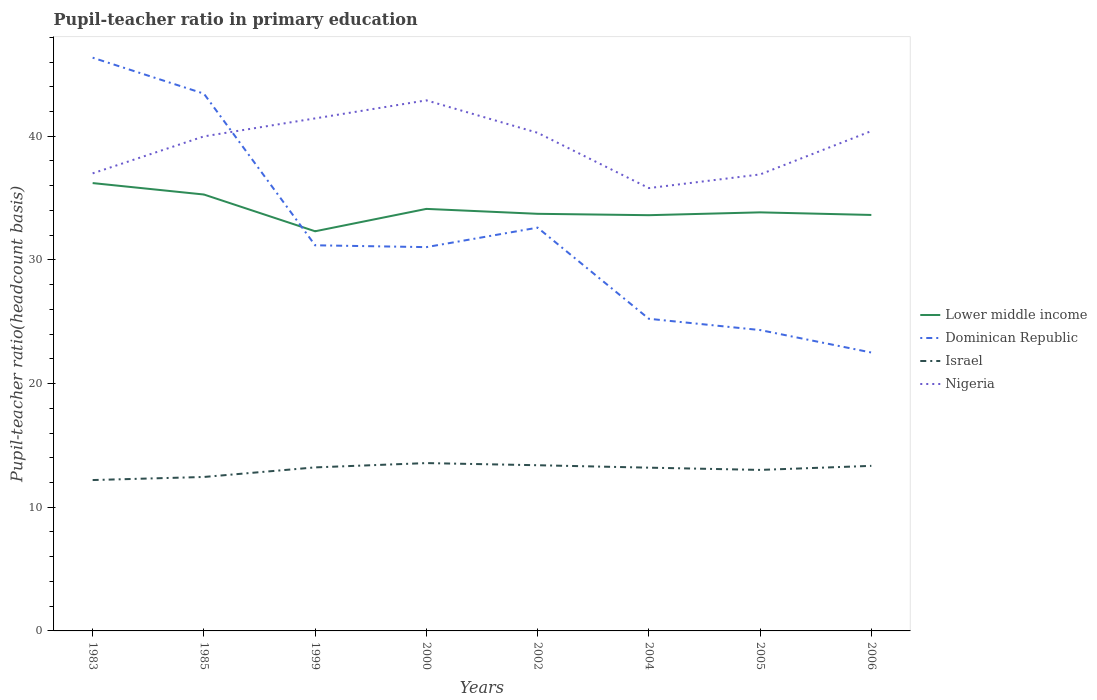Across all years, what is the maximum pupil-teacher ratio in primary education in Nigeria?
Provide a short and direct response. 35.81. In which year was the pupil-teacher ratio in primary education in Lower middle income maximum?
Ensure brevity in your answer.  1999. What is the total pupil-teacher ratio in primary education in Lower middle income in the graph?
Offer a very short reply. -0.23. What is the difference between the highest and the second highest pupil-teacher ratio in primary education in Lower middle income?
Give a very brief answer. 3.9. How many years are there in the graph?
Give a very brief answer. 8. What is the difference between two consecutive major ticks on the Y-axis?
Your answer should be compact. 10. Are the values on the major ticks of Y-axis written in scientific E-notation?
Provide a short and direct response. No. Does the graph contain grids?
Keep it short and to the point. No. Where does the legend appear in the graph?
Keep it short and to the point. Center right. How many legend labels are there?
Ensure brevity in your answer.  4. How are the legend labels stacked?
Provide a short and direct response. Vertical. What is the title of the graph?
Your response must be concise. Pupil-teacher ratio in primary education. Does "Mongolia" appear as one of the legend labels in the graph?
Your response must be concise. No. What is the label or title of the X-axis?
Your answer should be compact. Years. What is the label or title of the Y-axis?
Give a very brief answer. Pupil-teacher ratio(headcount basis). What is the Pupil-teacher ratio(headcount basis) in Lower middle income in 1983?
Your answer should be very brief. 36.21. What is the Pupil-teacher ratio(headcount basis) of Dominican Republic in 1983?
Your response must be concise. 46.35. What is the Pupil-teacher ratio(headcount basis) of Israel in 1983?
Your answer should be very brief. 12.2. What is the Pupil-teacher ratio(headcount basis) in Nigeria in 1983?
Give a very brief answer. 37. What is the Pupil-teacher ratio(headcount basis) of Lower middle income in 1985?
Provide a short and direct response. 35.29. What is the Pupil-teacher ratio(headcount basis) of Dominican Republic in 1985?
Your response must be concise. 43.44. What is the Pupil-teacher ratio(headcount basis) of Israel in 1985?
Your response must be concise. 12.45. What is the Pupil-teacher ratio(headcount basis) of Nigeria in 1985?
Make the answer very short. 39.99. What is the Pupil-teacher ratio(headcount basis) in Lower middle income in 1999?
Offer a very short reply. 32.31. What is the Pupil-teacher ratio(headcount basis) of Dominican Republic in 1999?
Provide a succinct answer. 31.18. What is the Pupil-teacher ratio(headcount basis) in Israel in 1999?
Your answer should be compact. 13.22. What is the Pupil-teacher ratio(headcount basis) of Nigeria in 1999?
Provide a succinct answer. 41.44. What is the Pupil-teacher ratio(headcount basis) of Lower middle income in 2000?
Your response must be concise. 34.12. What is the Pupil-teacher ratio(headcount basis) of Dominican Republic in 2000?
Make the answer very short. 31.03. What is the Pupil-teacher ratio(headcount basis) of Israel in 2000?
Your answer should be very brief. 13.57. What is the Pupil-teacher ratio(headcount basis) of Nigeria in 2000?
Ensure brevity in your answer.  42.9. What is the Pupil-teacher ratio(headcount basis) in Lower middle income in 2002?
Provide a short and direct response. 33.73. What is the Pupil-teacher ratio(headcount basis) in Dominican Republic in 2002?
Your response must be concise. 32.61. What is the Pupil-teacher ratio(headcount basis) in Israel in 2002?
Offer a terse response. 13.4. What is the Pupil-teacher ratio(headcount basis) in Nigeria in 2002?
Ensure brevity in your answer.  40.28. What is the Pupil-teacher ratio(headcount basis) of Lower middle income in 2004?
Offer a very short reply. 33.62. What is the Pupil-teacher ratio(headcount basis) of Dominican Republic in 2004?
Your answer should be compact. 25.24. What is the Pupil-teacher ratio(headcount basis) in Israel in 2004?
Keep it short and to the point. 13.2. What is the Pupil-teacher ratio(headcount basis) in Nigeria in 2004?
Provide a succinct answer. 35.81. What is the Pupil-teacher ratio(headcount basis) of Lower middle income in 2005?
Your answer should be compact. 33.84. What is the Pupil-teacher ratio(headcount basis) of Dominican Republic in 2005?
Offer a terse response. 24.33. What is the Pupil-teacher ratio(headcount basis) of Israel in 2005?
Your response must be concise. 13.02. What is the Pupil-teacher ratio(headcount basis) of Nigeria in 2005?
Your answer should be very brief. 36.91. What is the Pupil-teacher ratio(headcount basis) of Lower middle income in 2006?
Offer a terse response. 33.63. What is the Pupil-teacher ratio(headcount basis) in Dominican Republic in 2006?
Provide a short and direct response. 22.51. What is the Pupil-teacher ratio(headcount basis) of Israel in 2006?
Your answer should be compact. 13.35. What is the Pupil-teacher ratio(headcount basis) of Nigeria in 2006?
Your answer should be very brief. 40.42. Across all years, what is the maximum Pupil-teacher ratio(headcount basis) of Lower middle income?
Make the answer very short. 36.21. Across all years, what is the maximum Pupil-teacher ratio(headcount basis) of Dominican Republic?
Ensure brevity in your answer.  46.35. Across all years, what is the maximum Pupil-teacher ratio(headcount basis) in Israel?
Your answer should be very brief. 13.57. Across all years, what is the maximum Pupil-teacher ratio(headcount basis) of Nigeria?
Your answer should be very brief. 42.9. Across all years, what is the minimum Pupil-teacher ratio(headcount basis) in Lower middle income?
Provide a succinct answer. 32.31. Across all years, what is the minimum Pupil-teacher ratio(headcount basis) of Dominican Republic?
Keep it short and to the point. 22.51. Across all years, what is the minimum Pupil-teacher ratio(headcount basis) in Israel?
Offer a terse response. 12.2. Across all years, what is the minimum Pupil-teacher ratio(headcount basis) of Nigeria?
Offer a terse response. 35.81. What is the total Pupil-teacher ratio(headcount basis) in Lower middle income in the graph?
Your answer should be compact. 272.76. What is the total Pupil-teacher ratio(headcount basis) of Dominican Republic in the graph?
Give a very brief answer. 256.69. What is the total Pupil-teacher ratio(headcount basis) of Israel in the graph?
Provide a short and direct response. 104.4. What is the total Pupil-teacher ratio(headcount basis) of Nigeria in the graph?
Make the answer very short. 314.74. What is the difference between the Pupil-teacher ratio(headcount basis) of Lower middle income in 1983 and that in 1985?
Provide a succinct answer. 0.92. What is the difference between the Pupil-teacher ratio(headcount basis) in Dominican Republic in 1983 and that in 1985?
Your response must be concise. 2.91. What is the difference between the Pupil-teacher ratio(headcount basis) of Israel in 1983 and that in 1985?
Provide a succinct answer. -0.25. What is the difference between the Pupil-teacher ratio(headcount basis) of Nigeria in 1983 and that in 1985?
Your answer should be compact. -2.99. What is the difference between the Pupil-teacher ratio(headcount basis) of Lower middle income in 1983 and that in 1999?
Provide a succinct answer. 3.9. What is the difference between the Pupil-teacher ratio(headcount basis) of Dominican Republic in 1983 and that in 1999?
Your response must be concise. 15.17. What is the difference between the Pupil-teacher ratio(headcount basis) in Israel in 1983 and that in 1999?
Offer a terse response. -1.02. What is the difference between the Pupil-teacher ratio(headcount basis) of Nigeria in 1983 and that in 1999?
Offer a terse response. -4.44. What is the difference between the Pupil-teacher ratio(headcount basis) in Lower middle income in 1983 and that in 2000?
Your answer should be very brief. 2.09. What is the difference between the Pupil-teacher ratio(headcount basis) of Dominican Republic in 1983 and that in 2000?
Keep it short and to the point. 15.32. What is the difference between the Pupil-teacher ratio(headcount basis) of Israel in 1983 and that in 2000?
Your answer should be very brief. -1.37. What is the difference between the Pupil-teacher ratio(headcount basis) in Nigeria in 1983 and that in 2000?
Ensure brevity in your answer.  -5.9. What is the difference between the Pupil-teacher ratio(headcount basis) in Lower middle income in 1983 and that in 2002?
Give a very brief answer. 2.48. What is the difference between the Pupil-teacher ratio(headcount basis) in Dominican Republic in 1983 and that in 2002?
Make the answer very short. 13.74. What is the difference between the Pupil-teacher ratio(headcount basis) of Israel in 1983 and that in 2002?
Make the answer very short. -1.2. What is the difference between the Pupil-teacher ratio(headcount basis) of Nigeria in 1983 and that in 2002?
Your answer should be compact. -3.28. What is the difference between the Pupil-teacher ratio(headcount basis) of Lower middle income in 1983 and that in 2004?
Offer a very short reply. 2.6. What is the difference between the Pupil-teacher ratio(headcount basis) in Dominican Republic in 1983 and that in 2004?
Make the answer very short. 21.11. What is the difference between the Pupil-teacher ratio(headcount basis) in Israel in 1983 and that in 2004?
Make the answer very short. -1. What is the difference between the Pupil-teacher ratio(headcount basis) of Nigeria in 1983 and that in 2004?
Make the answer very short. 1.19. What is the difference between the Pupil-teacher ratio(headcount basis) in Lower middle income in 1983 and that in 2005?
Make the answer very short. 2.37. What is the difference between the Pupil-teacher ratio(headcount basis) in Dominican Republic in 1983 and that in 2005?
Your response must be concise. 22.02. What is the difference between the Pupil-teacher ratio(headcount basis) in Israel in 1983 and that in 2005?
Your answer should be compact. -0.82. What is the difference between the Pupil-teacher ratio(headcount basis) in Nigeria in 1983 and that in 2005?
Provide a succinct answer. 0.09. What is the difference between the Pupil-teacher ratio(headcount basis) of Lower middle income in 1983 and that in 2006?
Make the answer very short. 2.58. What is the difference between the Pupil-teacher ratio(headcount basis) of Dominican Republic in 1983 and that in 2006?
Your answer should be very brief. 23.84. What is the difference between the Pupil-teacher ratio(headcount basis) of Israel in 1983 and that in 2006?
Ensure brevity in your answer.  -1.15. What is the difference between the Pupil-teacher ratio(headcount basis) in Nigeria in 1983 and that in 2006?
Give a very brief answer. -3.42. What is the difference between the Pupil-teacher ratio(headcount basis) of Lower middle income in 1985 and that in 1999?
Provide a short and direct response. 2.97. What is the difference between the Pupil-teacher ratio(headcount basis) in Dominican Republic in 1985 and that in 1999?
Provide a succinct answer. 12.26. What is the difference between the Pupil-teacher ratio(headcount basis) of Israel in 1985 and that in 1999?
Ensure brevity in your answer.  -0.77. What is the difference between the Pupil-teacher ratio(headcount basis) in Nigeria in 1985 and that in 1999?
Offer a terse response. -1.45. What is the difference between the Pupil-teacher ratio(headcount basis) in Lower middle income in 1985 and that in 2000?
Provide a succinct answer. 1.16. What is the difference between the Pupil-teacher ratio(headcount basis) in Dominican Republic in 1985 and that in 2000?
Give a very brief answer. 12.41. What is the difference between the Pupil-teacher ratio(headcount basis) of Israel in 1985 and that in 2000?
Keep it short and to the point. -1.12. What is the difference between the Pupil-teacher ratio(headcount basis) in Nigeria in 1985 and that in 2000?
Provide a succinct answer. -2.91. What is the difference between the Pupil-teacher ratio(headcount basis) in Lower middle income in 1985 and that in 2002?
Make the answer very short. 1.56. What is the difference between the Pupil-teacher ratio(headcount basis) in Dominican Republic in 1985 and that in 2002?
Offer a terse response. 10.83. What is the difference between the Pupil-teacher ratio(headcount basis) of Israel in 1985 and that in 2002?
Keep it short and to the point. -0.95. What is the difference between the Pupil-teacher ratio(headcount basis) of Nigeria in 1985 and that in 2002?
Make the answer very short. -0.29. What is the difference between the Pupil-teacher ratio(headcount basis) in Lower middle income in 1985 and that in 2004?
Make the answer very short. 1.67. What is the difference between the Pupil-teacher ratio(headcount basis) of Dominican Republic in 1985 and that in 2004?
Keep it short and to the point. 18.2. What is the difference between the Pupil-teacher ratio(headcount basis) in Israel in 1985 and that in 2004?
Your answer should be compact. -0.75. What is the difference between the Pupil-teacher ratio(headcount basis) in Nigeria in 1985 and that in 2004?
Your answer should be compact. 4.18. What is the difference between the Pupil-teacher ratio(headcount basis) of Lower middle income in 1985 and that in 2005?
Provide a short and direct response. 1.44. What is the difference between the Pupil-teacher ratio(headcount basis) of Dominican Republic in 1985 and that in 2005?
Provide a succinct answer. 19.11. What is the difference between the Pupil-teacher ratio(headcount basis) in Israel in 1985 and that in 2005?
Your answer should be very brief. -0.57. What is the difference between the Pupil-teacher ratio(headcount basis) of Nigeria in 1985 and that in 2005?
Give a very brief answer. 3.08. What is the difference between the Pupil-teacher ratio(headcount basis) in Lower middle income in 1985 and that in 2006?
Offer a terse response. 1.65. What is the difference between the Pupil-teacher ratio(headcount basis) in Dominican Republic in 1985 and that in 2006?
Provide a short and direct response. 20.93. What is the difference between the Pupil-teacher ratio(headcount basis) in Israel in 1985 and that in 2006?
Provide a succinct answer. -0.9. What is the difference between the Pupil-teacher ratio(headcount basis) in Nigeria in 1985 and that in 2006?
Make the answer very short. -0.43. What is the difference between the Pupil-teacher ratio(headcount basis) of Lower middle income in 1999 and that in 2000?
Make the answer very short. -1.81. What is the difference between the Pupil-teacher ratio(headcount basis) of Dominican Republic in 1999 and that in 2000?
Ensure brevity in your answer.  0.15. What is the difference between the Pupil-teacher ratio(headcount basis) of Israel in 1999 and that in 2000?
Ensure brevity in your answer.  -0.35. What is the difference between the Pupil-teacher ratio(headcount basis) in Nigeria in 1999 and that in 2000?
Your response must be concise. -1.46. What is the difference between the Pupil-teacher ratio(headcount basis) in Lower middle income in 1999 and that in 2002?
Ensure brevity in your answer.  -1.41. What is the difference between the Pupil-teacher ratio(headcount basis) in Dominican Republic in 1999 and that in 2002?
Ensure brevity in your answer.  -1.43. What is the difference between the Pupil-teacher ratio(headcount basis) in Israel in 1999 and that in 2002?
Your response must be concise. -0.17. What is the difference between the Pupil-teacher ratio(headcount basis) in Nigeria in 1999 and that in 2002?
Provide a succinct answer. 1.17. What is the difference between the Pupil-teacher ratio(headcount basis) of Lower middle income in 1999 and that in 2004?
Provide a short and direct response. -1.3. What is the difference between the Pupil-teacher ratio(headcount basis) in Dominican Republic in 1999 and that in 2004?
Keep it short and to the point. 5.94. What is the difference between the Pupil-teacher ratio(headcount basis) of Israel in 1999 and that in 2004?
Your answer should be very brief. 0.02. What is the difference between the Pupil-teacher ratio(headcount basis) of Nigeria in 1999 and that in 2004?
Make the answer very short. 5.64. What is the difference between the Pupil-teacher ratio(headcount basis) in Lower middle income in 1999 and that in 2005?
Provide a short and direct response. -1.53. What is the difference between the Pupil-teacher ratio(headcount basis) of Dominican Republic in 1999 and that in 2005?
Provide a short and direct response. 6.85. What is the difference between the Pupil-teacher ratio(headcount basis) of Israel in 1999 and that in 2005?
Ensure brevity in your answer.  0.2. What is the difference between the Pupil-teacher ratio(headcount basis) of Nigeria in 1999 and that in 2005?
Your answer should be very brief. 4.53. What is the difference between the Pupil-teacher ratio(headcount basis) in Lower middle income in 1999 and that in 2006?
Provide a short and direct response. -1.32. What is the difference between the Pupil-teacher ratio(headcount basis) of Dominican Republic in 1999 and that in 2006?
Your response must be concise. 8.67. What is the difference between the Pupil-teacher ratio(headcount basis) in Israel in 1999 and that in 2006?
Keep it short and to the point. -0.12. What is the difference between the Pupil-teacher ratio(headcount basis) in Nigeria in 1999 and that in 2006?
Your answer should be very brief. 1.02. What is the difference between the Pupil-teacher ratio(headcount basis) in Lower middle income in 2000 and that in 2002?
Your answer should be compact. 0.4. What is the difference between the Pupil-teacher ratio(headcount basis) in Dominican Republic in 2000 and that in 2002?
Keep it short and to the point. -1.58. What is the difference between the Pupil-teacher ratio(headcount basis) in Israel in 2000 and that in 2002?
Provide a short and direct response. 0.17. What is the difference between the Pupil-teacher ratio(headcount basis) of Nigeria in 2000 and that in 2002?
Ensure brevity in your answer.  2.62. What is the difference between the Pupil-teacher ratio(headcount basis) of Lower middle income in 2000 and that in 2004?
Give a very brief answer. 0.51. What is the difference between the Pupil-teacher ratio(headcount basis) in Dominican Republic in 2000 and that in 2004?
Offer a very short reply. 5.79. What is the difference between the Pupil-teacher ratio(headcount basis) in Israel in 2000 and that in 2004?
Your response must be concise. 0.37. What is the difference between the Pupil-teacher ratio(headcount basis) of Nigeria in 2000 and that in 2004?
Keep it short and to the point. 7.09. What is the difference between the Pupil-teacher ratio(headcount basis) in Lower middle income in 2000 and that in 2005?
Your response must be concise. 0.28. What is the difference between the Pupil-teacher ratio(headcount basis) of Dominican Republic in 2000 and that in 2005?
Ensure brevity in your answer.  6.7. What is the difference between the Pupil-teacher ratio(headcount basis) of Israel in 2000 and that in 2005?
Keep it short and to the point. 0.55. What is the difference between the Pupil-teacher ratio(headcount basis) in Nigeria in 2000 and that in 2005?
Offer a terse response. 5.99. What is the difference between the Pupil-teacher ratio(headcount basis) in Lower middle income in 2000 and that in 2006?
Your answer should be compact. 0.49. What is the difference between the Pupil-teacher ratio(headcount basis) of Dominican Republic in 2000 and that in 2006?
Provide a short and direct response. 8.52. What is the difference between the Pupil-teacher ratio(headcount basis) of Israel in 2000 and that in 2006?
Provide a succinct answer. 0.22. What is the difference between the Pupil-teacher ratio(headcount basis) of Nigeria in 2000 and that in 2006?
Provide a succinct answer. 2.48. What is the difference between the Pupil-teacher ratio(headcount basis) of Lower middle income in 2002 and that in 2004?
Your response must be concise. 0.11. What is the difference between the Pupil-teacher ratio(headcount basis) in Dominican Republic in 2002 and that in 2004?
Offer a very short reply. 7.37. What is the difference between the Pupil-teacher ratio(headcount basis) in Israel in 2002 and that in 2004?
Keep it short and to the point. 0.2. What is the difference between the Pupil-teacher ratio(headcount basis) in Nigeria in 2002 and that in 2004?
Offer a terse response. 4.47. What is the difference between the Pupil-teacher ratio(headcount basis) of Lower middle income in 2002 and that in 2005?
Offer a terse response. -0.12. What is the difference between the Pupil-teacher ratio(headcount basis) of Dominican Republic in 2002 and that in 2005?
Give a very brief answer. 8.28. What is the difference between the Pupil-teacher ratio(headcount basis) of Israel in 2002 and that in 2005?
Ensure brevity in your answer.  0.38. What is the difference between the Pupil-teacher ratio(headcount basis) of Nigeria in 2002 and that in 2005?
Keep it short and to the point. 3.37. What is the difference between the Pupil-teacher ratio(headcount basis) in Lower middle income in 2002 and that in 2006?
Your answer should be compact. 0.09. What is the difference between the Pupil-teacher ratio(headcount basis) in Dominican Republic in 2002 and that in 2006?
Keep it short and to the point. 10.1. What is the difference between the Pupil-teacher ratio(headcount basis) of Israel in 2002 and that in 2006?
Keep it short and to the point. 0.05. What is the difference between the Pupil-teacher ratio(headcount basis) of Nigeria in 2002 and that in 2006?
Offer a very short reply. -0.14. What is the difference between the Pupil-teacher ratio(headcount basis) in Lower middle income in 2004 and that in 2005?
Keep it short and to the point. -0.23. What is the difference between the Pupil-teacher ratio(headcount basis) of Dominican Republic in 2004 and that in 2005?
Ensure brevity in your answer.  0.91. What is the difference between the Pupil-teacher ratio(headcount basis) of Israel in 2004 and that in 2005?
Your response must be concise. 0.18. What is the difference between the Pupil-teacher ratio(headcount basis) of Nigeria in 2004 and that in 2005?
Provide a short and direct response. -1.1. What is the difference between the Pupil-teacher ratio(headcount basis) in Lower middle income in 2004 and that in 2006?
Make the answer very short. -0.02. What is the difference between the Pupil-teacher ratio(headcount basis) of Dominican Republic in 2004 and that in 2006?
Give a very brief answer. 2.73. What is the difference between the Pupil-teacher ratio(headcount basis) of Israel in 2004 and that in 2006?
Provide a short and direct response. -0.15. What is the difference between the Pupil-teacher ratio(headcount basis) in Nigeria in 2004 and that in 2006?
Give a very brief answer. -4.61. What is the difference between the Pupil-teacher ratio(headcount basis) in Lower middle income in 2005 and that in 2006?
Make the answer very short. 0.21. What is the difference between the Pupil-teacher ratio(headcount basis) in Dominican Republic in 2005 and that in 2006?
Give a very brief answer. 1.82. What is the difference between the Pupil-teacher ratio(headcount basis) of Israel in 2005 and that in 2006?
Provide a succinct answer. -0.33. What is the difference between the Pupil-teacher ratio(headcount basis) of Nigeria in 2005 and that in 2006?
Give a very brief answer. -3.51. What is the difference between the Pupil-teacher ratio(headcount basis) of Lower middle income in 1983 and the Pupil-teacher ratio(headcount basis) of Dominican Republic in 1985?
Provide a succinct answer. -7.23. What is the difference between the Pupil-teacher ratio(headcount basis) of Lower middle income in 1983 and the Pupil-teacher ratio(headcount basis) of Israel in 1985?
Offer a very short reply. 23.76. What is the difference between the Pupil-teacher ratio(headcount basis) in Lower middle income in 1983 and the Pupil-teacher ratio(headcount basis) in Nigeria in 1985?
Provide a succinct answer. -3.78. What is the difference between the Pupil-teacher ratio(headcount basis) of Dominican Republic in 1983 and the Pupil-teacher ratio(headcount basis) of Israel in 1985?
Give a very brief answer. 33.9. What is the difference between the Pupil-teacher ratio(headcount basis) of Dominican Republic in 1983 and the Pupil-teacher ratio(headcount basis) of Nigeria in 1985?
Provide a short and direct response. 6.36. What is the difference between the Pupil-teacher ratio(headcount basis) in Israel in 1983 and the Pupil-teacher ratio(headcount basis) in Nigeria in 1985?
Ensure brevity in your answer.  -27.79. What is the difference between the Pupil-teacher ratio(headcount basis) in Lower middle income in 1983 and the Pupil-teacher ratio(headcount basis) in Dominican Republic in 1999?
Provide a short and direct response. 5.03. What is the difference between the Pupil-teacher ratio(headcount basis) in Lower middle income in 1983 and the Pupil-teacher ratio(headcount basis) in Israel in 1999?
Keep it short and to the point. 22.99. What is the difference between the Pupil-teacher ratio(headcount basis) in Lower middle income in 1983 and the Pupil-teacher ratio(headcount basis) in Nigeria in 1999?
Your answer should be very brief. -5.23. What is the difference between the Pupil-teacher ratio(headcount basis) in Dominican Republic in 1983 and the Pupil-teacher ratio(headcount basis) in Israel in 1999?
Provide a short and direct response. 33.13. What is the difference between the Pupil-teacher ratio(headcount basis) in Dominican Republic in 1983 and the Pupil-teacher ratio(headcount basis) in Nigeria in 1999?
Keep it short and to the point. 4.91. What is the difference between the Pupil-teacher ratio(headcount basis) in Israel in 1983 and the Pupil-teacher ratio(headcount basis) in Nigeria in 1999?
Your response must be concise. -29.24. What is the difference between the Pupil-teacher ratio(headcount basis) of Lower middle income in 1983 and the Pupil-teacher ratio(headcount basis) of Dominican Republic in 2000?
Give a very brief answer. 5.18. What is the difference between the Pupil-teacher ratio(headcount basis) in Lower middle income in 1983 and the Pupil-teacher ratio(headcount basis) in Israel in 2000?
Your answer should be very brief. 22.64. What is the difference between the Pupil-teacher ratio(headcount basis) in Lower middle income in 1983 and the Pupil-teacher ratio(headcount basis) in Nigeria in 2000?
Offer a very short reply. -6.69. What is the difference between the Pupil-teacher ratio(headcount basis) in Dominican Republic in 1983 and the Pupil-teacher ratio(headcount basis) in Israel in 2000?
Your answer should be very brief. 32.78. What is the difference between the Pupil-teacher ratio(headcount basis) of Dominican Republic in 1983 and the Pupil-teacher ratio(headcount basis) of Nigeria in 2000?
Provide a short and direct response. 3.45. What is the difference between the Pupil-teacher ratio(headcount basis) of Israel in 1983 and the Pupil-teacher ratio(headcount basis) of Nigeria in 2000?
Your answer should be very brief. -30.7. What is the difference between the Pupil-teacher ratio(headcount basis) of Lower middle income in 1983 and the Pupil-teacher ratio(headcount basis) of Dominican Republic in 2002?
Your answer should be very brief. 3.6. What is the difference between the Pupil-teacher ratio(headcount basis) in Lower middle income in 1983 and the Pupil-teacher ratio(headcount basis) in Israel in 2002?
Provide a succinct answer. 22.81. What is the difference between the Pupil-teacher ratio(headcount basis) of Lower middle income in 1983 and the Pupil-teacher ratio(headcount basis) of Nigeria in 2002?
Ensure brevity in your answer.  -4.07. What is the difference between the Pupil-teacher ratio(headcount basis) in Dominican Republic in 1983 and the Pupil-teacher ratio(headcount basis) in Israel in 2002?
Your response must be concise. 32.95. What is the difference between the Pupil-teacher ratio(headcount basis) of Dominican Republic in 1983 and the Pupil-teacher ratio(headcount basis) of Nigeria in 2002?
Make the answer very short. 6.07. What is the difference between the Pupil-teacher ratio(headcount basis) in Israel in 1983 and the Pupil-teacher ratio(headcount basis) in Nigeria in 2002?
Ensure brevity in your answer.  -28.08. What is the difference between the Pupil-teacher ratio(headcount basis) in Lower middle income in 1983 and the Pupil-teacher ratio(headcount basis) in Dominican Republic in 2004?
Your answer should be very brief. 10.97. What is the difference between the Pupil-teacher ratio(headcount basis) of Lower middle income in 1983 and the Pupil-teacher ratio(headcount basis) of Israel in 2004?
Provide a short and direct response. 23.01. What is the difference between the Pupil-teacher ratio(headcount basis) of Lower middle income in 1983 and the Pupil-teacher ratio(headcount basis) of Nigeria in 2004?
Your answer should be compact. 0.41. What is the difference between the Pupil-teacher ratio(headcount basis) in Dominican Republic in 1983 and the Pupil-teacher ratio(headcount basis) in Israel in 2004?
Your answer should be compact. 33.15. What is the difference between the Pupil-teacher ratio(headcount basis) of Dominican Republic in 1983 and the Pupil-teacher ratio(headcount basis) of Nigeria in 2004?
Your response must be concise. 10.54. What is the difference between the Pupil-teacher ratio(headcount basis) in Israel in 1983 and the Pupil-teacher ratio(headcount basis) in Nigeria in 2004?
Your answer should be very brief. -23.61. What is the difference between the Pupil-teacher ratio(headcount basis) of Lower middle income in 1983 and the Pupil-teacher ratio(headcount basis) of Dominican Republic in 2005?
Offer a very short reply. 11.88. What is the difference between the Pupil-teacher ratio(headcount basis) of Lower middle income in 1983 and the Pupil-teacher ratio(headcount basis) of Israel in 2005?
Provide a short and direct response. 23.19. What is the difference between the Pupil-teacher ratio(headcount basis) in Lower middle income in 1983 and the Pupil-teacher ratio(headcount basis) in Nigeria in 2005?
Offer a very short reply. -0.7. What is the difference between the Pupil-teacher ratio(headcount basis) in Dominican Republic in 1983 and the Pupil-teacher ratio(headcount basis) in Israel in 2005?
Keep it short and to the point. 33.33. What is the difference between the Pupil-teacher ratio(headcount basis) in Dominican Republic in 1983 and the Pupil-teacher ratio(headcount basis) in Nigeria in 2005?
Your answer should be compact. 9.44. What is the difference between the Pupil-teacher ratio(headcount basis) in Israel in 1983 and the Pupil-teacher ratio(headcount basis) in Nigeria in 2005?
Ensure brevity in your answer.  -24.71. What is the difference between the Pupil-teacher ratio(headcount basis) in Lower middle income in 1983 and the Pupil-teacher ratio(headcount basis) in Dominican Republic in 2006?
Make the answer very short. 13.7. What is the difference between the Pupil-teacher ratio(headcount basis) in Lower middle income in 1983 and the Pupil-teacher ratio(headcount basis) in Israel in 2006?
Your answer should be compact. 22.86. What is the difference between the Pupil-teacher ratio(headcount basis) of Lower middle income in 1983 and the Pupil-teacher ratio(headcount basis) of Nigeria in 2006?
Make the answer very short. -4.21. What is the difference between the Pupil-teacher ratio(headcount basis) of Dominican Republic in 1983 and the Pupil-teacher ratio(headcount basis) of Israel in 2006?
Your response must be concise. 33. What is the difference between the Pupil-teacher ratio(headcount basis) of Dominican Republic in 1983 and the Pupil-teacher ratio(headcount basis) of Nigeria in 2006?
Offer a terse response. 5.93. What is the difference between the Pupil-teacher ratio(headcount basis) of Israel in 1983 and the Pupil-teacher ratio(headcount basis) of Nigeria in 2006?
Ensure brevity in your answer.  -28.22. What is the difference between the Pupil-teacher ratio(headcount basis) in Lower middle income in 1985 and the Pupil-teacher ratio(headcount basis) in Dominican Republic in 1999?
Your answer should be very brief. 4.11. What is the difference between the Pupil-teacher ratio(headcount basis) of Lower middle income in 1985 and the Pupil-teacher ratio(headcount basis) of Israel in 1999?
Offer a terse response. 22.06. What is the difference between the Pupil-teacher ratio(headcount basis) of Lower middle income in 1985 and the Pupil-teacher ratio(headcount basis) of Nigeria in 1999?
Your response must be concise. -6.15. What is the difference between the Pupil-teacher ratio(headcount basis) of Dominican Republic in 1985 and the Pupil-teacher ratio(headcount basis) of Israel in 1999?
Keep it short and to the point. 30.22. What is the difference between the Pupil-teacher ratio(headcount basis) of Dominican Republic in 1985 and the Pupil-teacher ratio(headcount basis) of Nigeria in 1999?
Give a very brief answer. 2. What is the difference between the Pupil-teacher ratio(headcount basis) of Israel in 1985 and the Pupil-teacher ratio(headcount basis) of Nigeria in 1999?
Your answer should be compact. -28.99. What is the difference between the Pupil-teacher ratio(headcount basis) in Lower middle income in 1985 and the Pupil-teacher ratio(headcount basis) in Dominican Republic in 2000?
Give a very brief answer. 4.25. What is the difference between the Pupil-teacher ratio(headcount basis) in Lower middle income in 1985 and the Pupil-teacher ratio(headcount basis) in Israel in 2000?
Your answer should be very brief. 21.72. What is the difference between the Pupil-teacher ratio(headcount basis) of Lower middle income in 1985 and the Pupil-teacher ratio(headcount basis) of Nigeria in 2000?
Your response must be concise. -7.61. What is the difference between the Pupil-teacher ratio(headcount basis) in Dominican Republic in 1985 and the Pupil-teacher ratio(headcount basis) in Israel in 2000?
Keep it short and to the point. 29.87. What is the difference between the Pupil-teacher ratio(headcount basis) of Dominican Republic in 1985 and the Pupil-teacher ratio(headcount basis) of Nigeria in 2000?
Your response must be concise. 0.54. What is the difference between the Pupil-teacher ratio(headcount basis) in Israel in 1985 and the Pupil-teacher ratio(headcount basis) in Nigeria in 2000?
Offer a very short reply. -30.45. What is the difference between the Pupil-teacher ratio(headcount basis) in Lower middle income in 1985 and the Pupil-teacher ratio(headcount basis) in Dominican Republic in 2002?
Make the answer very short. 2.68. What is the difference between the Pupil-teacher ratio(headcount basis) in Lower middle income in 1985 and the Pupil-teacher ratio(headcount basis) in Israel in 2002?
Offer a terse response. 21.89. What is the difference between the Pupil-teacher ratio(headcount basis) of Lower middle income in 1985 and the Pupil-teacher ratio(headcount basis) of Nigeria in 2002?
Your answer should be very brief. -4.99. What is the difference between the Pupil-teacher ratio(headcount basis) of Dominican Republic in 1985 and the Pupil-teacher ratio(headcount basis) of Israel in 2002?
Provide a succinct answer. 30.05. What is the difference between the Pupil-teacher ratio(headcount basis) of Dominican Republic in 1985 and the Pupil-teacher ratio(headcount basis) of Nigeria in 2002?
Make the answer very short. 3.17. What is the difference between the Pupil-teacher ratio(headcount basis) of Israel in 1985 and the Pupil-teacher ratio(headcount basis) of Nigeria in 2002?
Offer a terse response. -27.83. What is the difference between the Pupil-teacher ratio(headcount basis) in Lower middle income in 1985 and the Pupil-teacher ratio(headcount basis) in Dominican Republic in 2004?
Give a very brief answer. 10.05. What is the difference between the Pupil-teacher ratio(headcount basis) of Lower middle income in 1985 and the Pupil-teacher ratio(headcount basis) of Israel in 2004?
Give a very brief answer. 22.09. What is the difference between the Pupil-teacher ratio(headcount basis) of Lower middle income in 1985 and the Pupil-teacher ratio(headcount basis) of Nigeria in 2004?
Give a very brief answer. -0.52. What is the difference between the Pupil-teacher ratio(headcount basis) in Dominican Republic in 1985 and the Pupil-teacher ratio(headcount basis) in Israel in 2004?
Your response must be concise. 30.24. What is the difference between the Pupil-teacher ratio(headcount basis) in Dominican Republic in 1985 and the Pupil-teacher ratio(headcount basis) in Nigeria in 2004?
Provide a short and direct response. 7.64. What is the difference between the Pupil-teacher ratio(headcount basis) in Israel in 1985 and the Pupil-teacher ratio(headcount basis) in Nigeria in 2004?
Give a very brief answer. -23.36. What is the difference between the Pupil-teacher ratio(headcount basis) in Lower middle income in 1985 and the Pupil-teacher ratio(headcount basis) in Dominican Republic in 2005?
Offer a terse response. 10.96. What is the difference between the Pupil-teacher ratio(headcount basis) of Lower middle income in 1985 and the Pupil-teacher ratio(headcount basis) of Israel in 2005?
Offer a terse response. 22.27. What is the difference between the Pupil-teacher ratio(headcount basis) in Lower middle income in 1985 and the Pupil-teacher ratio(headcount basis) in Nigeria in 2005?
Ensure brevity in your answer.  -1.62. What is the difference between the Pupil-teacher ratio(headcount basis) in Dominican Republic in 1985 and the Pupil-teacher ratio(headcount basis) in Israel in 2005?
Provide a succinct answer. 30.42. What is the difference between the Pupil-teacher ratio(headcount basis) of Dominican Republic in 1985 and the Pupil-teacher ratio(headcount basis) of Nigeria in 2005?
Provide a succinct answer. 6.53. What is the difference between the Pupil-teacher ratio(headcount basis) of Israel in 1985 and the Pupil-teacher ratio(headcount basis) of Nigeria in 2005?
Offer a terse response. -24.46. What is the difference between the Pupil-teacher ratio(headcount basis) of Lower middle income in 1985 and the Pupil-teacher ratio(headcount basis) of Dominican Republic in 2006?
Ensure brevity in your answer.  12.78. What is the difference between the Pupil-teacher ratio(headcount basis) of Lower middle income in 1985 and the Pupil-teacher ratio(headcount basis) of Israel in 2006?
Your answer should be compact. 21.94. What is the difference between the Pupil-teacher ratio(headcount basis) in Lower middle income in 1985 and the Pupil-teacher ratio(headcount basis) in Nigeria in 2006?
Provide a succinct answer. -5.13. What is the difference between the Pupil-teacher ratio(headcount basis) in Dominican Republic in 1985 and the Pupil-teacher ratio(headcount basis) in Israel in 2006?
Make the answer very short. 30.1. What is the difference between the Pupil-teacher ratio(headcount basis) in Dominican Republic in 1985 and the Pupil-teacher ratio(headcount basis) in Nigeria in 2006?
Your answer should be compact. 3.03. What is the difference between the Pupil-teacher ratio(headcount basis) of Israel in 1985 and the Pupil-teacher ratio(headcount basis) of Nigeria in 2006?
Provide a succinct answer. -27.97. What is the difference between the Pupil-teacher ratio(headcount basis) in Lower middle income in 1999 and the Pupil-teacher ratio(headcount basis) in Dominican Republic in 2000?
Your response must be concise. 1.28. What is the difference between the Pupil-teacher ratio(headcount basis) in Lower middle income in 1999 and the Pupil-teacher ratio(headcount basis) in Israel in 2000?
Your answer should be compact. 18.74. What is the difference between the Pupil-teacher ratio(headcount basis) in Lower middle income in 1999 and the Pupil-teacher ratio(headcount basis) in Nigeria in 2000?
Ensure brevity in your answer.  -10.59. What is the difference between the Pupil-teacher ratio(headcount basis) of Dominican Republic in 1999 and the Pupil-teacher ratio(headcount basis) of Israel in 2000?
Ensure brevity in your answer.  17.61. What is the difference between the Pupil-teacher ratio(headcount basis) of Dominican Republic in 1999 and the Pupil-teacher ratio(headcount basis) of Nigeria in 2000?
Keep it short and to the point. -11.72. What is the difference between the Pupil-teacher ratio(headcount basis) of Israel in 1999 and the Pupil-teacher ratio(headcount basis) of Nigeria in 2000?
Offer a terse response. -29.68. What is the difference between the Pupil-teacher ratio(headcount basis) in Lower middle income in 1999 and the Pupil-teacher ratio(headcount basis) in Dominican Republic in 2002?
Your response must be concise. -0.29. What is the difference between the Pupil-teacher ratio(headcount basis) of Lower middle income in 1999 and the Pupil-teacher ratio(headcount basis) of Israel in 2002?
Provide a succinct answer. 18.92. What is the difference between the Pupil-teacher ratio(headcount basis) of Lower middle income in 1999 and the Pupil-teacher ratio(headcount basis) of Nigeria in 2002?
Offer a terse response. -7.96. What is the difference between the Pupil-teacher ratio(headcount basis) of Dominican Republic in 1999 and the Pupil-teacher ratio(headcount basis) of Israel in 2002?
Make the answer very short. 17.78. What is the difference between the Pupil-teacher ratio(headcount basis) of Dominican Republic in 1999 and the Pupil-teacher ratio(headcount basis) of Nigeria in 2002?
Keep it short and to the point. -9.1. What is the difference between the Pupil-teacher ratio(headcount basis) in Israel in 1999 and the Pupil-teacher ratio(headcount basis) in Nigeria in 2002?
Provide a short and direct response. -27.05. What is the difference between the Pupil-teacher ratio(headcount basis) in Lower middle income in 1999 and the Pupil-teacher ratio(headcount basis) in Dominican Republic in 2004?
Make the answer very short. 7.08. What is the difference between the Pupil-teacher ratio(headcount basis) of Lower middle income in 1999 and the Pupil-teacher ratio(headcount basis) of Israel in 2004?
Give a very brief answer. 19.11. What is the difference between the Pupil-teacher ratio(headcount basis) of Lower middle income in 1999 and the Pupil-teacher ratio(headcount basis) of Nigeria in 2004?
Your answer should be compact. -3.49. What is the difference between the Pupil-teacher ratio(headcount basis) of Dominican Republic in 1999 and the Pupil-teacher ratio(headcount basis) of Israel in 2004?
Your answer should be compact. 17.98. What is the difference between the Pupil-teacher ratio(headcount basis) in Dominican Republic in 1999 and the Pupil-teacher ratio(headcount basis) in Nigeria in 2004?
Your answer should be very brief. -4.63. What is the difference between the Pupil-teacher ratio(headcount basis) in Israel in 1999 and the Pupil-teacher ratio(headcount basis) in Nigeria in 2004?
Provide a succinct answer. -22.58. What is the difference between the Pupil-teacher ratio(headcount basis) in Lower middle income in 1999 and the Pupil-teacher ratio(headcount basis) in Dominican Republic in 2005?
Ensure brevity in your answer.  7.99. What is the difference between the Pupil-teacher ratio(headcount basis) of Lower middle income in 1999 and the Pupil-teacher ratio(headcount basis) of Israel in 2005?
Provide a short and direct response. 19.3. What is the difference between the Pupil-teacher ratio(headcount basis) of Lower middle income in 1999 and the Pupil-teacher ratio(headcount basis) of Nigeria in 2005?
Make the answer very short. -4.6. What is the difference between the Pupil-teacher ratio(headcount basis) in Dominican Republic in 1999 and the Pupil-teacher ratio(headcount basis) in Israel in 2005?
Ensure brevity in your answer.  18.16. What is the difference between the Pupil-teacher ratio(headcount basis) in Dominican Republic in 1999 and the Pupil-teacher ratio(headcount basis) in Nigeria in 2005?
Make the answer very short. -5.73. What is the difference between the Pupil-teacher ratio(headcount basis) in Israel in 1999 and the Pupil-teacher ratio(headcount basis) in Nigeria in 2005?
Your answer should be compact. -23.69. What is the difference between the Pupil-teacher ratio(headcount basis) in Lower middle income in 1999 and the Pupil-teacher ratio(headcount basis) in Dominican Republic in 2006?
Give a very brief answer. 9.8. What is the difference between the Pupil-teacher ratio(headcount basis) in Lower middle income in 1999 and the Pupil-teacher ratio(headcount basis) in Israel in 2006?
Give a very brief answer. 18.97. What is the difference between the Pupil-teacher ratio(headcount basis) of Lower middle income in 1999 and the Pupil-teacher ratio(headcount basis) of Nigeria in 2006?
Offer a very short reply. -8.1. What is the difference between the Pupil-teacher ratio(headcount basis) in Dominican Republic in 1999 and the Pupil-teacher ratio(headcount basis) in Israel in 2006?
Offer a terse response. 17.83. What is the difference between the Pupil-teacher ratio(headcount basis) of Dominican Republic in 1999 and the Pupil-teacher ratio(headcount basis) of Nigeria in 2006?
Keep it short and to the point. -9.24. What is the difference between the Pupil-teacher ratio(headcount basis) in Israel in 1999 and the Pupil-teacher ratio(headcount basis) in Nigeria in 2006?
Your answer should be very brief. -27.19. What is the difference between the Pupil-teacher ratio(headcount basis) in Lower middle income in 2000 and the Pupil-teacher ratio(headcount basis) in Dominican Republic in 2002?
Offer a terse response. 1.52. What is the difference between the Pupil-teacher ratio(headcount basis) of Lower middle income in 2000 and the Pupil-teacher ratio(headcount basis) of Israel in 2002?
Keep it short and to the point. 20.73. What is the difference between the Pupil-teacher ratio(headcount basis) of Lower middle income in 2000 and the Pupil-teacher ratio(headcount basis) of Nigeria in 2002?
Provide a short and direct response. -6.15. What is the difference between the Pupil-teacher ratio(headcount basis) in Dominican Republic in 2000 and the Pupil-teacher ratio(headcount basis) in Israel in 2002?
Your answer should be compact. 17.64. What is the difference between the Pupil-teacher ratio(headcount basis) in Dominican Republic in 2000 and the Pupil-teacher ratio(headcount basis) in Nigeria in 2002?
Your response must be concise. -9.24. What is the difference between the Pupil-teacher ratio(headcount basis) of Israel in 2000 and the Pupil-teacher ratio(headcount basis) of Nigeria in 2002?
Give a very brief answer. -26.71. What is the difference between the Pupil-teacher ratio(headcount basis) in Lower middle income in 2000 and the Pupil-teacher ratio(headcount basis) in Dominican Republic in 2004?
Your response must be concise. 8.89. What is the difference between the Pupil-teacher ratio(headcount basis) in Lower middle income in 2000 and the Pupil-teacher ratio(headcount basis) in Israel in 2004?
Your response must be concise. 20.92. What is the difference between the Pupil-teacher ratio(headcount basis) of Lower middle income in 2000 and the Pupil-teacher ratio(headcount basis) of Nigeria in 2004?
Give a very brief answer. -1.68. What is the difference between the Pupil-teacher ratio(headcount basis) in Dominican Republic in 2000 and the Pupil-teacher ratio(headcount basis) in Israel in 2004?
Your answer should be very brief. 17.83. What is the difference between the Pupil-teacher ratio(headcount basis) of Dominican Republic in 2000 and the Pupil-teacher ratio(headcount basis) of Nigeria in 2004?
Your answer should be compact. -4.77. What is the difference between the Pupil-teacher ratio(headcount basis) in Israel in 2000 and the Pupil-teacher ratio(headcount basis) in Nigeria in 2004?
Give a very brief answer. -22.24. What is the difference between the Pupil-teacher ratio(headcount basis) in Lower middle income in 2000 and the Pupil-teacher ratio(headcount basis) in Dominican Republic in 2005?
Your response must be concise. 9.8. What is the difference between the Pupil-teacher ratio(headcount basis) in Lower middle income in 2000 and the Pupil-teacher ratio(headcount basis) in Israel in 2005?
Give a very brief answer. 21.11. What is the difference between the Pupil-teacher ratio(headcount basis) in Lower middle income in 2000 and the Pupil-teacher ratio(headcount basis) in Nigeria in 2005?
Provide a short and direct response. -2.79. What is the difference between the Pupil-teacher ratio(headcount basis) of Dominican Republic in 2000 and the Pupil-teacher ratio(headcount basis) of Israel in 2005?
Your response must be concise. 18.01. What is the difference between the Pupil-teacher ratio(headcount basis) in Dominican Republic in 2000 and the Pupil-teacher ratio(headcount basis) in Nigeria in 2005?
Offer a very short reply. -5.88. What is the difference between the Pupil-teacher ratio(headcount basis) of Israel in 2000 and the Pupil-teacher ratio(headcount basis) of Nigeria in 2005?
Provide a short and direct response. -23.34. What is the difference between the Pupil-teacher ratio(headcount basis) in Lower middle income in 2000 and the Pupil-teacher ratio(headcount basis) in Dominican Republic in 2006?
Keep it short and to the point. 11.61. What is the difference between the Pupil-teacher ratio(headcount basis) of Lower middle income in 2000 and the Pupil-teacher ratio(headcount basis) of Israel in 2006?
Provide a succinct answer. 20.78. What is the difference between the Pupil-teacher ratio(headcount basis) of Lower middle income in 2000 and the Pupil-teacher ratio(headcount basis) of Nigeria in 2006?
Your answer should be compact. -6.29. What is the difference between the Pupil-teacher ratio(headcount basis) of Dominican Republic in 2000 and the Pupil-teacher ratio(headcount basis) of Israel in 2006?
Your answer should be very brief. 17.69. What is the difference between the Pupil-teacher ratio(headcount basis) of Dominican Republic in 2000 and the Pupil-teacher ratio(headcount basis) of Nigeria in 2006?
Make the answer very short. -9.38. What is the difference between the Pupil-teacher ratio(headcount basis) of Israel in 2000 and the Pupil-teacher ratio(headcount basis) of Nigeria in 2006?
Provide a short and direct response. -26.85. What is the difference between the Pupil-teacher ratio(headcount basis) of Lower middle income in 2002 and the Pupil-teacher ratio(headcount basis) of Dominican Republic in 2004?
Offer a terse response. 8.49. What is the difference between the Pupil-teacher ratio(headcount basis) of Lower middle income in 2002 and the Pupil-teacher ratio(headcount basis) of Israel in 2004?
Offer a very short reply. 20.53. What is the difference between the Pupil-teacher ratio(headcount basis) of Lower middle income in 2002 and the Pupil-teacher ratio(headcount basis) of Nigeria in 2004?
Ensure brevity in your answer.  -2.08. What is the difference between the Pupil-teacher ratio(headcount basis) of Dominican Republic in 2002 and the Pupil-teacher ratio(headcount basis) of Israel in 2004?
Your answer should be compact. 19.41. What is the difference between the Pupil-teacher ratio(headcount basis) of Dominican Republic in 2002 and the Pupil-teacher ratio(headcount basis) of Nigeria in 2004?
Provide a succinct answer. -3.2. What is the difference between the Pupil-teacher ratio(headcount basis) of Israel in 2002 and the Pupil-teacher ratio(headcount basis) of Nigeria in 2004?
Your answer should be compact. -22.41. What is the difference between the Pupil-teacher ratio(headcount basis) of Lower middle income in 2002 and the Pupil-teacher ratio(headcount basis) of Dominican Republic in 2005?
Offer a terse response. 9.4. What is the difference between the Pupil-teacher ratio(headcount basis) of Lower middle income in 2002 and the Pupil-teacher ratio(headcount basis) of Israel in 2005?
Ensure brevity in your answer.  20.71. What is the difference between the Pupil-teacher ratio(headcount basis) of Lower middle income in 2002 and the Pupil-teacher ratio(headcount basis) of Nigeria in 2005?
Keep it short and to the point. -3.18. What is the difference between the Pupil-teacher ratio(headcount basis) of Dominican Republic in 2002 and the Pupil-teacher ratio(headcount basis) of Israel in 2005?
Ensure brevity in your answer.  19.59. What is the difference between the Pupil-teacher ratio(headcount basis) in Dominican Republic in 2002 and the Pupil-teacher ratio(headcount basis) in Nigeria in 2005?
Provide a short and direct response. -4.3. What is the difference between the Pupil-teacher ratio(headcount basis) in Israel in 2002 and the Pupil-teacher ratio(headcount basis) in Nigeria in 2005?
Offer a very short reply. -23.51. What is the difference between the Pupil-teacher ratio(headcount basis) of Lower middle income in 2002 and the Pupil-teacher ratio(headcount basis) of Dominican Republic in 2006?
Offer a very short reply. 11.22. What is the difference between the Pupil-teacher ratio(headcount basis) of Lower middle income in 2002 and the Pupil-teacher ratio(headcount basis) of Israel in 2006?
Provide a short and direct response. 20.38. What is the difference between the Pupil-teacher ratio(headcount basis) in Lower middle income in 2002 and the Pupil-teacher ratio(headcount basis) in Nigeria in 2006?
Your response must be concise. -6.69. What is the difference between the Pupil-teacher ratio(headcount basis) in Dominican Republic in 2002 and the Pupil-teacher ratio(headcount basis) in Israel in 2006?
Your answer should be very brief. 19.26. What is the difference between the Pupil-teacher ratio(headcount basis) in Dominican Republic in 2002 and the Pupil-teacher ratio(headcount basis) in Nigeria in 2006?
Give a very brief answer. -7.81. What is the difference between the Pupil-teacher ratio(headcount basis) of Israel in 2002 and the Pupil-teacher ratio(headcount basis) of Nigeria in 2006?
Your answer should be compact. -27.02. What is the difference between the Pupil-teacher ratio(headcount basis) of Lower middle income in 2004 and the Pupil-teacher ratio(headcount basis) of Dominican Republic in 2005?
Your answer should be compact. 9.29. What is the difference between the Pupil-teacher ratio(headcount basis) of Lower middle income in 2004 and the Pupil-teacher ratio(headcount basis) of Israel in 2005?
Offer a very short reply. 20.6. What is the difference between the Pupil-teacher ratio(headcount basis) of Lower middle income in 2004 and the Pupil-teacher ratio(headcount basis) of Nigeria in 2005?
Your response must be concise. -3.29. What is the difference between the Pupil-teacher ratio(headcount basis) in Dominican Republic in 2004 and the Pupil-teacher ratio(headcount basis) in Israel in 2005?
Your answer should be very brief. 12.22. What is the difference between the Pupil-teacher ratio(headcount basis) in Dominican Republic in 2004 and the Pupil-teacher ratio(headcount basis) in Nigeria in 2005?
Provide a succinct answer. -11.67. What is the difference between the Pupil-teacher ratio(headcount basis) of Israel in 2004 and the Pupil-teacher ratio(headcount basis) of Nigeria in 2005?
Your answer should be compact. -23.71. What is the difference between the Pupil-teacher ratio(headcount basis) of Lower middle income in 2004 and the Pupil-teacher ratio(headcount basis) of Dominican Republic in 2006?
Your response must be concise. 11.1. What is the difference between the Pupil-teacher ratio(headcount basis) of Lower middle income in 2004 and the Pupil-teacher ratio(headcount basis) of Israel in 2006?
Your response must be concise. 20.27. What is the difference between the Pupil-teacher ratio(headcount basis) of Lower middle income in 2004 and the Pupil-teacher ratio(headcount basis) of Nigeria in 2006?
Give a very brief answer. -6.8. What is the difference between the Pupil-teacher ratio(headcount basis) in Dominican Republic in 2004 and the Pupil-teacher ratio(headcount basis) in Israel in 2006?
Keep it short and to the point. 11.89. What is the difference between the Pupil-teacher ratio(headcount basis) in Dominican Republic in 2004 and the Pupil-teacher ratio(headcount basis) in Nigeria in 2006?
Keep it short and to the point. -15.18. What is the difference between the Pupil-teacher ratio(headcount basis) of Israel in 2004 and the Pupil-teacher ratio(headcount basis) of Nigeria in 2006?
Provide a short and direct response. -27.22. What is the difference between the Pupil-teacher ratio(headcount basis) in Lower middle income in 2005 and the Pupil-teacher ratio(headcount basis) in Dominican Republic in 2006?
Your answer should be very brief. 11.33. What is the difference between the Pupil-teacher ratio(headcount basis) in Lower middle income in 2005 and the Pupil-teacher ratio(headcount basis) in Israel in 2006?
Provide a succinct answer. 20.5. What is the difference between the Pupil-teacher ratio(headcount basis) in Lower middle income in 2005 and the Pupil-teacher ratio(headcount basis) in Nigeria in 2006?
Provide a succinct answer. -6.57. What is the difference between the Pupil-teacher ratio(headcount basis) of Dominican Republic in 2005 and the Pupil-teacher ratio(headcount basis) of Israel in 2006?
Provide a succinct answer. 10.98. What is the difference between the Pupil-teacher ratio(headcount basis) of Dominican Republic in 2005 and the Pupil-teacher ratio(headcount basis) of Nigeria in 2006?
Ensure brevity in your answer.  -16.09. What is the difference between the Pupil-teacher ratio(headcount basis) in Israel in 2005 and the Pupil-teacher ratio(headcount basis) in Nigeria in 2006?
Provide a succinct answer. -27.4. What is the average Pupil-teacher ratio(headcount basis) of Lower middle income per year?
Offer a very short reply. 34.09. What is the average Pupil-teacher ratio(headcount basis) of Dominican Republic per year?
Offer a very short reply. 32.09. What is the average Pupil-teacher ratio(headcount basis) in Israel per year?
Offer a very short reply. 13.05. What is the average Pupil-teacher ratio(headcount basis) in Nigeria per year?
Make the answer very short. 39.34. In the year 1983, what is the difference between the Pupil-teacher ratio(headcount basis) in Lower middle income and Pupil-teacher ratio(headcount basis) in Dominican Republic?
Your answer should be very brief. -10.14. In the year 1983, what is the difference between the Pupil-teacher ratio(headcount basis) in Lower middle income and Pupil-teacher ratio(headcount basis) in Israel?
Ensure brevity in your answer.  24.01. In the year 1983, what is the difference between the Pupil-teacher ratio(headcount basis) in Lower middle income and Pupil-teacher ratio(headcount basis) in Nigeria?
Keep it short and to the point. -0.79. In the year 1983, what is the difference between the Pupil-teacher ratio(headcount basis) in Dominican Republic and Pupil-teacher ratio(headcount basis) in Israel?
Ensure brevity in your answer.  34.15. In the year 1983, what is the difference between the Pupil-teacher ratio(headcount basis) in Dominican Republic and Pupil-teacher ratio(headcount basis) in Nigeria?
Give a very brief answer. 9.35. In the year 1983, what is the difference between the Pupil-teacher ratio(headcount basis) in Israel and Pupil-teacher ratio(headcount basis) in Nigeria?
Give a very brief answer. -24.8. In the year 1985, what is the difference between the Pupil-teacher ratio(headcount basis) of Lower middle income and Pupil-teacher ratio(headcount basis) of Dominican Republic?
Your response must be concise. -8.16. In the year 1985, what is the difference between the Pupil-teacher ratio(headcount basis) of Lower middle income and Pupil-teacher ratio(headcount basis) of Israel?
Give a very brief answer. 22.84. In the year 1985, what is the difference between the Pupil-teacher ratio(headcount basis) in Lower middle income and Pupil-teacher ratio(headcount basis) in Nigeria?
Keep it short and to the point. -4.7. In the year 1985, what is the difference between the Pupil-teacher ratio(headcount basis) in Dominican Republic and Pupil-teacher ratio(headcount basis) in Israel?
Provide a short and direct response. 30.99. In the year 1985, what is the difference between the Pupil-teacher ratio(headcount basis) in Dominican Republic and Pupil-teacher ratio(headcount basis) in Nigeria?
Offer a terse response. 3.46. In the year 1985, what is the difference between the Pupil-teacher ratio(headcount basis) of Israel and Pupil-teacher ratio(headcount basis) of Nigeria?
Make the answer very short. -27.54. In the year 1999, what is the difference between the Pupil-teacher ratio(headcount basis) in Lower middle income and Pupil-teacher ratio(headcount basis) in Dominican Republic?
Provide a short and direct response. 1.13. In the year 1999, what is the difference between the Pupil-teacher ratio(headcount basis) of Lower middle income and Pupil-teacher ratio(headcount basis) of Israel?
Make the answer very short. 19.09. In the year 1999, what is the difference between the Pupil-teacher ratio(headcount basis) in Lower middle income and Pupil-teacher ratio(headcount basis) in Nigeria?
Offer a very short reply. -9.13. In the year 1999, what is the difference between the Pupil-teacher ratio(headcount basis) in Dominican Republic and Pupil-teacher ratio(headcount basis) in Israel?
Keep it short and to the point. 17.96. In the year 1999, what is the difference between the Pupil-teacher ratio(headcount basis) in Dominican Republic and Pupil-teacher ratio(headcount basis) in Nigeria?
Ensure brevity in your answer.  -10.26. In the year 1999, what is the difference between the Pupil-teacher ratio(headcount basis) in Israel and Pupil-teacher ratio(headcount basis) in Nigeria?
Offer a terse response. -28.22. In the year 2000, what is the difference between the Pupil-teacher ratio(headcount basis) in Lower middle income and Pupil-teacher ratio(headcount basis) in Dominican Republic?
Ensure brevity in your answer.  3.09. In the year 2000, what is the difference between the Pupil-teacher ratio(headcount basis) in Lower middle income and Pupil-teacher ratio(headcount basis) in Israel?
Your response must be concise. 20.55. In the year 2000, what is the difference between the Pupil-teacher ratio(headcount basis) of Lower middle income and Pupil-teacher ratio(headcount basis) of Nigeria?
Offer a very short reply. -8.78. In the year 2000, what is the difference between the Pupil-teacher ratio(headcount basis) of Dominican Republic and Pupil-teacher ratio(headcount basis) of Israel?
Provide a succinct answer. 17.46. In the year 2000, what is the difference between the Pupil-teacher ratio(headcount basis) in Dominican Republic and Pupil-teacher ratio(headcount basis) in Nigeria?
Give a very brief answer. -11.87. In the year 2000, what is the difference between the Pupil-teacher ratio(headcount basis) of Israel and Pupil-teacher ratio(headcount basis) of Nigeria?
Provide a short and direct response. -29.33. In the year 2002, what is the difference between the Pupil-teacher ratio(headcount basis) of Lower middle income and Pupil-teacher ratio(headcount basis) of Dominican Republic?
Your answer should be compact. 1.12. In the year 2002, what is the difference between the Pupil-teacher ratio(headcount basis) in Lower middle income and Pupil-teacher ratio(headcount basis) in Israel?
Make the answer very short. 20.33. In the year 2002, what is the difference between the Pupil-teacher ratio(headcount basis) in Lower middle income and Pupil-teacher ratio(headcount basis) in Nigeria?
Give a very brief answer. -6.55. In the year 2002, what is the difference between the Pupil-teacher ratio(headcount basis) of Dominican Republic and Pupil-teacher ratio(headcount basis) of Israel?
Make the answer very short. 19.21. In the year 2002, what is the difference between the Pupil-teacher ratio(headcount basis) in Dominican Republic and Pupil-teacher ratio(headcount basis) in Nigeria?
Provide a succinct answer. -7.67. In the year 2002, what is the difference between the Pupil-teacher ratio(headcount basis) of Israel and Pupil-teacher ratio(headcount basis) of Nigeria?
Make the answer very short. -26.88. In the year 2004, what is the difference between the Pupil-teacher ratio(headcount basis) in Lower middle income and Pupil-teacher ratio(headcount basis) in Dominican Republic?
Your answer should be compact. 8.38. In the year 2004, what is the difference between the Pupil-teacher ratio(headcount basis) in Lower middle income and Pupil-teacher ratio(headcount basis) in Israel?
Give a very brief answer. 20.41. In the year 2004, what is the difference between the Pupil-teacher ratio(headcount basis) of Lower middle income and Pupil-teacher ratio(headcount basis) of Nigeria?
Offer a terse response. -2.19. In the year 2004, what is the difference between the Pupil-teacher ratio(headcount basis) of Dominican Republic and Pupil-teacher ratio(headcount basis) of Israel?
Ensure brevity in your answer.  12.04. In the year 2004, what is the difference between the Pupil-teacher ratio(headcount basis) in Dominican Republic and Pupil-teacher ratio(headcount basis) in Nigeria?
Provide a succinct answer. -10.57. In the year 2004, what is the difference between the Pupil-teacher ratio(headcount basis) in Israel and Pupil-teacher ratio(headcount basis) in Nigeria?
Give a very brief answer. -22.61. In the year 2005, what is the difference between the Pupil-teacher ratio(headcount basis) in Lower middle income and Pupil-teacher ratio(headcount basis) in Dominican Republic?
Provide a succinct answer. 9.52. In the year 2005, what is the difference between the Pupil-teacher ratio(headcount basis) in Lower middle income and Pupil-teacher ratio(headcount basis) in Israel?
Ensure brevity in your answer.  20.83. In the year 2005, what is the difference between the Pupil-teacher ratio(headcount basis) in Lower middle income and Pupil-teacher ratio(headcount basis) in Nigeria?
Offer a very short reply. -3.07. In the year 2005, what is the difference between the Pupil-teacher ratio(headcount basis) of Dominican Republic and Pupil-teacher ratio(headcount basis) of Israel?
Provide a short and direct response. 11.31. In the year 2005, what is the difference between the Pupil-teacher ratio(headcount basis) of Dominican Republic and Pupil-teacher ratio(headcount basis) of Nigeria?
Your response must be concise. -12.58. In the year 2005, what is the difference between the Pupil-teacher ratio(headcount basis) of Israel and Pupil-teacher ratio(headcount basis) of Nigeria?
Provide a short and direct response. -23.89. In the year 2006, what is the difference between the Pupil-teacher ratio(headcount basis) of Lower middle income and Pupil-teacher ratio(headcount basis) of Dominican Republic?
Give a very brief answer. 11.12. In the year 2006, what is the difference between the Pupil-teacher ratio(headcount basis) of Lower middle income and Pupil-teacher ratio(headcount basis) of Israel?
Your response must be concise. 20.29. In the year 2006, what is the difference between the Pupil-teacher ratio(headcount basis) in Lower middle income and Pupil-teacher ratio(headcount basis) in Nigeria?
Ensure brevity in your answer.  -6.78. In the year 2006, what is the difference between the Pupil-teacher ratio(headcount basis) of Dominican Republic and Pupil-teacher ratio(headcount basis) of Israel?
Your response must be concise. 9.16. In the year 2006, what is the difference between the Pupil-teacher ratio(headcount basis) in Dominican Republic and Pupil-teacher ratio(headcount basis) in Nigeria?
Offer a terse response. -17.91. In the year 2006, what is the difference between the Pupil-teacher ratio(headcount basis) in Israel and Pupil-teacher ratio(headcount basis) in Nigeria?
Make the answer very short. -27.07. What is the ratio of the Pupil-teacher ratio(headcount basis) in Lower middle income in 1983 to that in 1985?
Your answer should be compact. 1.03. What is the ratio of the Pupil-teacher ratio(headcount basis) in Dominican Republic in 1983 to that in 1985?
Ensure brevity in your answer.  1.07. What is the ratio of the Pupil-teacher ratio(headcount basis) in Nigeria in 1983 to that in 1985?
Provide a succinct answer. 0.93. What is the ratio of the Pupil-teacher ratio(headcount basis) in Lower middle income in 1983 to that in 1999?
Make the answer very short. 1.12. What is the ratio of the Pupil-teacher ratio(headcount basis) in Dominican Republic in 1983 to that in 1999?
Your answer should be very brief. 1.49. What is the ratio of the Pupil-teacher ratio(headcount basis) in Israel in 1983 to that in 1999?
Offer a terse response. 0.92. What is the ratio of the Pupil-teacher ratio(headcount basis) in Nigeria in 1983 to that in 1999?
Provide a short and direct response. 0.89. What is the ratio of the Pupil-teacher ratio(headcount basis) in Lower middle income in 1983 to that in 2000?
Keep it short and to the point. 1.06. What is the ratio of the Pupil-teacher ratio(headcount basis) in Dominican Republic in 1983 to that in 2000?
Offer a very short reply. 1.49. What is the ratio of the Pupil-teacher ratio(headcount basis) of Israel in 1983 to that in 2000?
Provide a short and direct response. 0.9. What is the ratio of the Pupil-teacher ratio(headcount basis) of Nigeria in 1983 to that in 2000?
Your response must be concise. 0.86. What is the ratio of the Pupil-teacher ratio(headcount basis) of Lower middle income in 1983 to that in 2002?
Ensure brevity in your answer.  1.07. What is the ratio of the Pupil-teacher ratio(headcount basis) of Dominican Republic in 1983 to that in 2002?
Make the answer very short. 1.42. What is the ratio of the Pupil-teacher ratio(headcount basis) in Israel in 1983 to that in 2002?
Give a very brief answer. 0.91. What is the ratio of the Pupil-teacher ratio(headcount basis) of Nigeria in 1983 to that in 2002?
Offer a very short reply. 0.92. What is the ratio of the Pupil-teacher ratio(headcount basis) of Lower middle income in 1983 to that in 2004?
Your answer should be very brief. 1.08. What is the ratio of the Pupil-teacher ratio(headcount basis) of Dominican Republic in 1983 to that in 2004?
Your answer should be compact. 1.84. What is the ratio of the Pupil-teacher ratio(headcount basis) in Israel in 1983 to that in 2004?
Your answer should be compact. 0.92. What is the ratio of the Pupil-teacher ratio(headcount basis) of Nigeria in 1983 to that in 2004?
Give a very brief answer. 1.03. What is the ratio of the Pupil-teacher ratio(headcount basis) of Lower middle income in 1983 to that in 2005?
Offer a terse response. 1.07. What is the ratio of the Pupil-teacher ratio(headcount basis) in Dominican Republic in 1983 to that in 2005?
Keep it short and to the point. 1.91. What is the ratio of the Pupil-teacher ratio(headcount basis) of Israel in 1983 to that in 2005?
Your answer should be very brief. 0.94. What is the ratio of the Pupil-teacher ratio(headcount basis) of Lower middle income in 1983 to that in 2006?
Offer a terse response. 1.08. What is the ratio of the Pupil-teacher ratio(headcount basis) in Dominican Republic in 1983 to that in 2006?
Keep it short and to the point. 2.06. What is the ratio of the Pupil-teacher ratio(headcount basis) of Israel in 1983 to that in 2006?
Ensure brevity in your answer.  0.91. What is the ratio of the Pupil-teacher ratio(headcount basis) of Nigeria in 1983 to that in 2006?
Offer a terse response. 0.92. What is the ratio of the Pupil-teacher ratio(headcount basis) in Lower middle income in 1985 to that in 1999?
Offer a very short reply. 1.09. What is the ratio of the Pupil-teacher ratio(headcount basis) in Dominican Republic in 1985 to that in 1999?
Provide a short and direct response. 1.39. What is the ratio of the Pupil-teacher ratio(headcount basis) of Israel in 1985 to that in 1999?
Provide a short and direct response. 0.94. What is the ratio of the Pupil-teacher ratio(headcount basis) in Nigeria in 1985 to that in 1999?
Provide a succinct answer. 0.96. What is the ratio of the Pupil-teacher ratio(headcount basis) of Lower middle income in 1985 to that in 2000?
Offer a very short reply. 1.03. What is the ratio of the Pupil-teacher ratio(headcount basis) in Dominican Republic in 1985 to that in 2000?
Make the answer very short. 1.4. What is the ratio of the Pupil-teacher ratio(headcount basis) in Israel in 1985 to that in 2000?
Your answer should be compact. 0.92. What is the ratio of the Pupil-teacher ratio(headcount basis) of Nigeria in 1985 to that in 2000?
Keep it short and to the point. 0.93. What is the ratio of the Pupil-teacher ratio(headcount basis) of Lower middle income in 1985 to that in 2002?
Ensure brevity in your answer.  1.05. What is the ratio of the Pupil-teacher ratio(headcount basis) of Dominican Republic in 1985 to that in 2002?
Your response must be concise. 1.33. What is the ratio of the Pupil-teacher ratio(headcount basis) of Israel in 1985 to that in 2002?
Provide a short and direct response. 0.93. What is the ratio of the Pupil-teacher ratio(headcount basis) in Nigeria in 1985 to that in 2002?
Give a very brief answer. 0.99. What is the ratio of the Pupil-teacher ratio(headcount basis) of Lower middle income in 1985 to that in 2004?
Your answer should be very brief. 1.05. What is the ratio of the Pupil-teacher ratio(headcount basis) in Dominican Republic in 1985 to that in 2004?
Your answer should be very brief. 1.72. What is the ratio of the Pupil-teacher ratio(headcount basis) of Israel in 1985 to that in 2004?
Keep it short and to the point. 0.94. What is the ratio of the Pupil-teacher ratio(headcount basis) of Nigeria in 1985 to that in 2004?
Keep it short and to the point. 1.12. What is the ratio of the Pupil-teacher ratio(headcount basis) in Lower middle income in 1985 to that in 2005?
Offer a terse response. 1.04. What is the ratio of the Pupil-teacher ratio(headcount basis) of Dominican Republic in 1985 to that in 2005?
Keep it short and to the point. 1.79. What is the ratio of the Pupil-teacher ratio(headcount basis) of Israel in 1985 to that in 2005?
Your response must be concise. 0.96. What is the ratio of the Pupil-teacher ratio(headcount basis) of Nigeria in 1985 to that in 2005?
Offer a terse response. 1.08. What is the ratio of the Pupil-teacher ratio(headcount basis) in Lower middle income in 1985 to that in 2006?
Your answer should be compact. 1.05. What is the ratio of the Pupil-teacher ratio(headcount basis) in Dominican Republic in 1985 to that in 2006?
Offer a terse response. 1.93. What is the ratio of the Pupil-teacher ratio(headcount basis) of Israel in 1985 to that in 2006?
Offer a terse response. 0.93. What is the ratio of the Pupil-teacher ratio(headcount basis) of Lower middle income in 1999 to that in 2000?
Give a very brief answer. 0.95. What is the ratio of the Pupil-teacher ratio(headcount basis) in Israel in 1999 to that in 2000?
Offer a very short reply. 0.97. What is the ratio of the Pupil-teacher ratio(headcount basis) of Nigeria in 1999 to that in 2000?
Your response must be concise. 0.97. What is the ratio of the Pupil-teacher ratio(headcount basis) in Lower middle income in 1999 to that in 2002?
Ensure brevity in your answer.  0.96. What is the ratio of the Pupil-teacher ratio(headcount basis) in Dominican Republic in 1999 to that in 2002?
Make the answer very short. 0.96. What is the ratio of the Pupil-teacher ratio(headcount basis) in Nigeria in 1999 to that in 2002?
Offer a very short reply. 1.03. What is the ratio of the Pupil-teacher ratio(headcount basis) in Lower middle income in 1999 to that in 2004?
Make the answer very short. 0.96. What is the ratio of the Pupil-teacher ratio(headcount basis) in Dominican Republic in 1999 to that in 2004?
Provide a succinct answer. 1.24. What is the ratio of the Pupil-teacher ratio(headcount basis) in Israel in 1999 to that in 2004?
Ensure brevity in your answer.  1. What is the ratio of the Pupil-teacher ratio(headcount basis) of Nigeria in 1999 to that in 2004?
Your answer should be compact. 1.16. What is the ratio of the Pupil-teacher ratio(headcount basis) in Lower middle income in 1999 to that in 2005?
Provide a succinct answer. 0.95. What is the ratio of the Pupil-teacher ratio(headcount basis) of Dominican Republic in 1999 to that in 2005?
Offer a terse response. 1.28. What is the ratio of the Pupil-teacher ratio(headcount basis) in Israel in 1999 to that in 2005?
Give a very brief answer. 1.02. What is the ratio of the Pupil-teacher ratio(headcount basis) in Nigeria in 1999 to that in 2005?
Your answer should be very brief. 1.12. What is the ratio of the Pupil-teacher ratio(headcount basis) in Lower middle income in 1999 to that in 2006?
Provide a short and direct response. 0.96. What is the ratio of the Pupil-teacher ratio(headcount basis) of Dominican Republic in 1999 to that in 2006?
Your response must be concise. 1.39. What is the ratio of the Pupil-teacher ratio(headcount basis) of Israel in 1999 to that in 2006?
Provide a short and direct response. 0.99. What is the ratio of the Pupil-teacher ratio(headcount basis) of Nigeria in 1999 to that in 2006?
Provide a succinct answer. 1.03. What is the ratio of the Pupil-teacher ratio(headcount basis) in Lower middle income in 2000 to that in 2002?
Your answer should be very brief. 1.01. What is the ratio of the Pupil-teacher ratio(headcount basis) in Dominican Republic in 2000 to that in 2002?
Offer a terse response. 0.95. What is the ratio of the Pupil-teacher ratio(headcount basis) of Israel in 2000 to that in 2002?
Your answer should be compact. 1.01. What is the ratio of the Pupil-teacher ratio(headcount basis) in Nigeria in 2000 to that in 2002?
Offer a terse response. 1.07. What is the ratio of the Pupil-teacher ratio(headcount basis) in Lower middle income in 2000 to that in 2004?
Your answer should be compact. 1.02. What is the ratio of the Pupil-teacher ratio(headcount basis) in Dominican Republic in 2000 to that in 2004?
Give a very brief answer. 1.23. What is the ratio of the Pupil-teacher ratio(headcount basis) of Israel in 2000 to that in 2004?
Provide a short and direct response. 1.03. What is the ratio of the Pupil-teacher ratio(headcount basis) of Nigeria in 2000 to that in 2004?
Make the answer very short. 1.2. What is the ratio of the Pupil-teacher ratio(headcount basis) in Lower middle income in 2000 to that in 2005?
Provide a succinct answer. 1.01. What is the ratio of the Pupil-teacher ratio(headcount basis) of Dominican Republic in 2000 to that in 2005?
Give a very brief answer. 1.28. What is the ratio of the Pupil-teacher ratio(headcount basis) of Israel in 2000 to that in 2005?
Give a very brief answer. 1.04. What is the ratio of the Pupil-teacher ratio(headcount basis) in Nigeria in 2000 to that in 2005?
Make the answer very short. 1.16. What is the ratio of the Pupil-teacher ratio(headcount basis) in Lower middle income in 2000 to that in 2006?
Provide a short and direct response. 1.01. What is the ratio of the Pupil-teacher ratio(headcount basis) of Dominican Republic in 2000 to that in 2006?
Provide a succinct answer. 1.38. What is the ratio of the Pupil-teacher ratio(headcount basis) in Israel in 2000 to that in 2006?
Give a very brief answer. 1.02. What is the ratio of the Pupil-teacher ratio(headcount basis) in Nigeria in 2000 to that in 2006?
Keep it short and to the point. 1.06. What is the ratio of the Pupil-teacher ratio(headcount basis) in Dominican Republic in 2002 to that in 2004?
Keep it short and to the point. 1.29. What is the ratio of the Pupil-teacher ratio(headcount basis) in Israel in 2002 to that in 2004?
Offer a very short reply. 1.01. What is the ratio of the Pupil-teacher ratio(headcount basis) in Nigeria in 2002 to that in 2004?
Your response must be concise. 1.12. What is the ratio of the Pupil-teacher ratio(headcount basis) of Dominican Republic in 2002 to that in 2005?
Give a very brief answer. 1.34. What is the ratio of the Pupil-teacher ratio(headcount basis) of Israel in 2002 to that in 2005?
Give a very brief answer. 1.03. What is the ratio of the Pupil-teacher ratio(headcount basis) in Nigeria in 2002 to that in 2005?
Your answer should be compact. 1.09. What is the ratio of the Pupil-teacher ratio(headcount basis) of Lower middle income in 2002 to that in 2006?
Keep it short and to the point. 1. What is the ratio of the Pupil-teacher ratio(headcount basis) in Dominican Republic in 2002 to that in 2006?
Make the answer very short. 1.45. What is the ratio of the Pupil-teacher ratio(headcount basis) in Israel in 2002 to that in 2006?
Give a very brief answer. 1. What is the ratio of the Pupil-teacher ratio(headcount basis) in Dominican Republic in 2004 to that in 2005?
Keep it short and to the point. 1.04. What is the ratio of the Pupil-teacher ratio(headcount basis) in Nigeria in 2004 to that in 2005?
Make the answer very short. 0.97. What is the ratio of the Pupil-teacher ratio(headcount basis) in Lower middle income in 2004 to that in 2006?
Your response must be concise. 1. What is the ratio of the Pupil-teacher ratio(headcount basis) of Dominican Republic in 2004 to that in 2006?
Your answer should be compact. 1.12. What is the ratio of the Pupil-teacher ratio(headcount basis) in Nigeria in 2004 to that in 2006?
Provide a succinct answer. 0.89. What is the ratio of the Pupil-teacher ratio(headcount basis) of Lower middle income in 2005 to that in 2006?
Make the answer very short. 1.01. What is the ratio of the Pupil-teacher ratio(headcount basis) in Dominican Republic in 2005 to that in 2006?
Offer a terse response. 1.08. What is the ratio of the Pupil-teacher ratio(headcount basis) in Israel in 2005 to that in 2006?
Offer a terse response. 0.98. What is the ratio of the Pupil-teacher ratio(headcount basis) of Nigeria in 2005 to that in 2006?
Give a very brief answer. 0.91. What is the difference between the highest and the second highest Pupil-teacher ratio(headcount basis) in Lower middle income?
Offer a very short reply. 0.92. What is the difference between the highest and the second highest Pupil-teacher ratio(headcount basis) in Dominican Republic?
Keep it short and to the point. 2.91. What is the difference between the highest and the second highest Pupil-teacher ratio(headcount basis) of Israel?
Ensure brevity in your answer.  0.17. What is the difference between the highest and the second highest Pupil-teacher ratio(headcount basis) in Nigeria?
Provide a succinct answer. 1.46. What is the difference between the highest and the lowest Pupil-teacher ratio(headcount basis) of Lower middle income?
Provide a short and direct response. 3.9. What is the difference between the highest and the lowest Pupil-teacher ratio(headcount basis) of Dominican Republic?
Keep it short and to the point. 23.84. What is the difference between the highest and the lowest Pupil-teacher ratio(headcount basis) of Israel?
Give a very brief answer. 1.37. What is the difference between the highest and the lowest Pupil-teacher ratio(headcount basis) of Nigeria?
Make the answer very short. 7.09. 